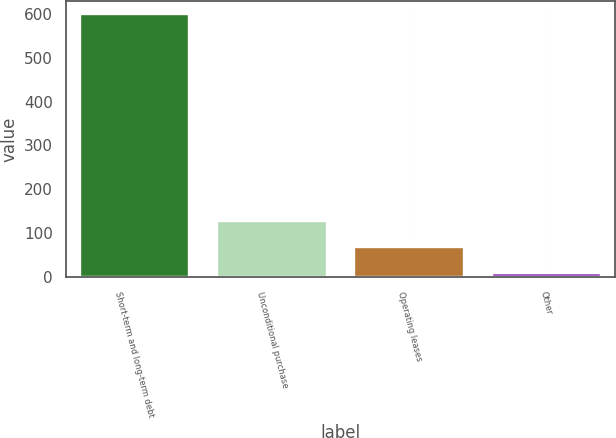<chart> <loc_0><loc_0><loc_500><loc_500><bar_chart><fcel>Short-term and long-term debt<fcel>Unconditional purchase<fcel>Operating leases<fcel>Other<nl><fcel>600<fcel>127.2<fcel>68.1<fcel>9<nl></chart> 